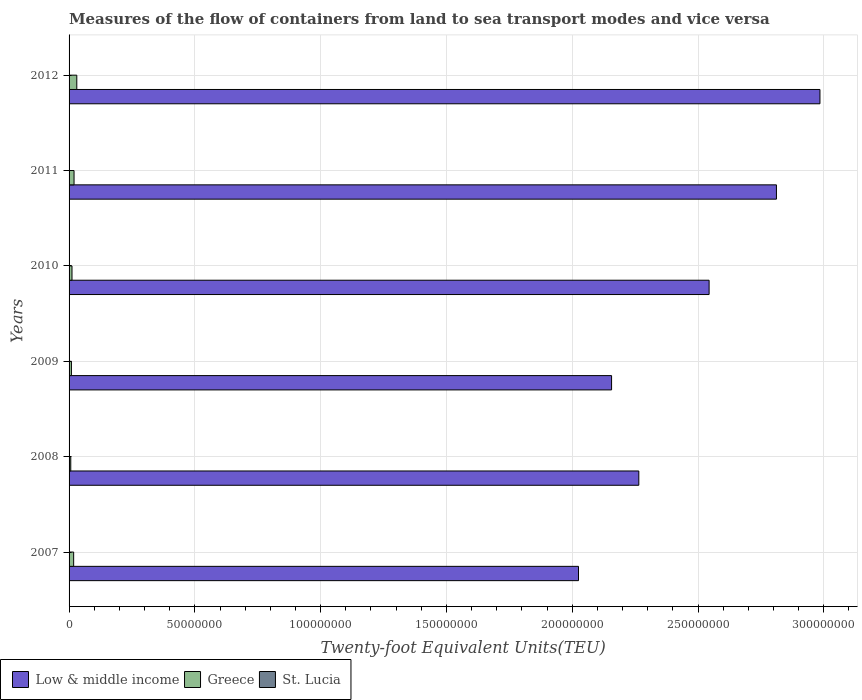How many groups of bars are there?
Your response must be concise. 6. How many bars are there on the 4th tick from the bottom?
Keep it short and to the point. 3. What is the container port traffic in St. Lucia in 2011?
Keep it short and to the point. 5.85e+04. Across all years, what is the maximum container port traffic in Greece?
Provide a succinct answer. 3.07e+06. Across all years, what is the minimum container port traffic in St. Lucia?
Give a very brief answer. 5.19e+04. In which year was the container port traffic in Low & middle income minimum?
Make the answer very short. 2007. What is the total container port traffic in St. Lucia in the graph?
Provide a succinct answer. 3.52e+05. What is the difference between the container port traffic in St. Lucia in 2008 and that in 2009?
Keep it short and to the point. 1.83e+04. What is the difference between the container port traffic in Low & middle income in 2009 and the container port traffic in St. Lucia in 2012?
Your response must be concise. 2.16e+08. What is the average container port traffic in Greece per year?
Ensure brevity in your answer.  1.61e+06. In the year 2008, what is the difference between the container port traffic in Low & middle income and container port traffic in St. Lucia?
Your answer should be very brief. 2.26e+08. In how many years, is the container port traffic in Greece greater than 280000000 TEU?
Offer a terse response. 0. What is the ratio of the container port traffic in Low & middle income in 2007 to that in 2008?
Provide a short and direct response. 0.89. Is the difference between the container port traffic in Low & middle income in 2010 and 2011 greater than the difference between the container port traffic in St. Lucia in 2010 and 2011?
Ensure brevity in your answer.  No. What is the difference between the highest and the second highest container port traffic in Greece?
Your response must be concise. 1.09e+06. What is the difference between the highest and the lowest container port traffic in St. Lucia?
Provide a short and direct response. 1.83e+04. In how many years, is the container port traffic in Greece greater than the average container port traffic in Greece taken over all years?
Your answer should be very brief. 3. Is the sum of the container port traffic in Low & middle income in 2008 and 2011 greater than the maximum container port traffic in St. Lucia across all years?
Keep it short and to the point. Yes. What does the 1st bar from the top in 2010 represents?
Your answer should be very brief. St. Lucia. What does the 3rd bar from the bottom in 2008 represents?
Your answer should be very brief. St. Lucia. Is it the case that in every year, the sum of the container port traffic in St. Lucia and container port traffic in Low & middle income is greater than the container port traffic in Greece?
Offer a very short reply. Yes. How many bars are there?
Ensure brevity in your answer.  18. Are all the bars in the graph horizontal?
Offer a terse response. Yes. How many years are there in the graph?
Your response must be concise. 6. Are the values on the major ticks of X-axis written in scientific E-notation?
Your answer should be very brief. No. Does the graph contain any zero values?
Keep it short and to the point. No. Does the graph contain grids?
Provide a succinct answer. Yes. How many legend labels are there?
Your response must be concise. 3. How are the legend labels stacked?
Provide a short and direct response. Horizontal. What is the title of the graph?
Ensure brevity in your answer.  Measures of the flow of containers from land to sea transport modes and vice versa. Does "Barbados" appear as one of the legend labels in the graph?
Ensure brevity in your answer.  No. What is the label or title of the X-axis?
Your answer should be very brief. Twenty-foot Equivalent Units(TEU). What is the Twenty-foot Equivalent Units(TEU) in Low & middle income in 2007?
Provide a succinct answer. 2.02e+08. What is the Twenty-foot Equivalent Units(TEU) in Greece in 2007?
Your response must be concise. 1.82e+06. What is the Twenty-foot Equivalent Units(TEU) of St. Lucia in 2007?
Your response must be concise. 5.56e+04. What is the Twenty-foot Equivalent Units(TEU) in Low & middle income in 2008?
Your answer should be very brief. 2.26e+08. What is the Twenty-foot Equivalent Units(TEU) in Greece in 2008?
Offer a very short reply. 6.73e+05. What is the Twenty-foot Equivalent Units(TEU) in St. Lucia in 2008?
Your answer should be compact. 7.02e+04. What is the Twenty-foot Equivalent Units(TEU) in Low & middle income in 2009?
Offer a very short reply. 2.16e+08. What is the Twenty-foot Equivalent Units(TEU) of Greece in 2009?
Your response must be concise. 9.35e+05. What is the Twenty-foot Equivalent Units(TEU) of St. Lucia in 2009?
Offer a terse response. 5.19e+04. What is the Twenty-foot Equivalent Units(TEU) of Low & middle income in 2010?
Offer a terse response. 2.54e+08. What is the Twenty-foot Equivalent Units(TEU) in Greece in 2010?
Provide a succinct answer. 1.17e+06. What is the Twenty-foot Equivalent Units(TEU) of St. Lucia in 2010?
Offer a terse response. 5.25e+04. What is the Twenty-foot Equivalent Units(TEU) of Low & middle income in 2011?
Provide a succinct answer. 2.81e+08. What is the Twenty-foot Equivalent Units(TEU) in Greece in 2011?
Keep it short and to the point. 1.98e+06. What is the Twenty-foot Equivalent Units(TEU) of St. Lucia in 2011?
Provide a succinct answer. 5.85e+04. What is the Twenty-foot Equivalent Units(TEU) in Low & middle income in 2012?
Ensure brevity in your answer.  2.98e+08. What is the Twenty-foot Equivalent Units(TEU) in Greece in 2012?
Give a very brief answer. 3.07e+06. What is the Twenty-foot Equivalent Units(TEU) of St. Lucia in 2012?
Your response must be concise. 6.29e+04. Across all years, what is the maximum Twenty-foot Equivalent Units(TEU) in Low & middle income?
Your answer should be compact. 2.98e+08. Across all years, what is the maximum Twenty-foot Equivalent Units(TEU) of Greece?
Offer a terse response. 3.07e+06. Across all years, what is the maximum Twenty-foot Equivalent Units(TEU) of St. Lucia?
Make the answer very short. 7.02e+04. Across all years, what is the minimum Twenty-foot Equivalent Units(TEU) of Low & middle income?
Your answer should be compact. 2.02e+08. Across all years, what is the minimum Twenty-foot Equivalent Units(TEU) in Greece?
Your answer should be compact. 6.73e+05. Across all years, what is the minimum Twenty-foot Equivalent Units(TEU) of St. Lucia?
Your answer should be compact. 5.19e+04. What is the total Twenty-foot Equivalent Units(TEU) of Low & middle income in the graph?
Offer a very short reply. 1.48e+09. What is the total Twenty-foot Equivalent Units(TEU) in Greece in the graph?
Give a very brief answer. 9.64e+06. What is the total Twenty-foot Equivalent Units(TEU) of St. Lucia in the graph?
Your response must be concise. 3.52e+05. What is the difference between the Twenty-foot Equivalent Units(TEU) in Low & middle income in 2007 and that in 2008?
Your answer should be very brief. -2.40e+07. What is the difference between the Twenty-foot Equivalent Units(TEU) in Greece in 2007 and that in 2008?
Make the answer very short. 1.15e+06. What is the difference between the Twenty-foot Equivalent Units(TEU) in St. Lucia in 2007 and that in 2008?
Offer a very short reply. -1.46e+04. What is the difference between the Twenty-foot Equivalent Units(TEU) in Low & middle income in 2007 and that in 2009?
Ensure brevity in your answer.  -1.32e+07. What is the difference between the Twenty-foot Equivalent Units(TEU) in Greece in 2007 and that in 2009?
Ensure brevity in your answer.  8.85e+05. What is the difference between the Twenty-foot Equivalent Units(TEU) of St. Lucia in 2007 and that in 2009?
Offer a terse response. 3640. What is the difference between the Twenty-foot Equivalent Units(TEU) in Low & middle income in 2007 and that in 2010?
Keep it short and to the point. -5.19e+07. What is the difference between the Twenty-foot Equivalent Units(TEU) in Greece in 2007 and that in 2010?
Provide a short and direct response. 6.55e+05. What is the difference between the Twenty-foot Equivalent Units(TEU) in St. Lucia in 2007 and that in 2010?
Make the answer very short. 3103. What is the difference between the Twenty-foot Equivalent Units(TEU) in Low & middle income in 2007 and that in 2011?
Offer a terse response. -7.87e+07. What is the difference between the Twenty-foot Equivalent Units(TEU) of Greece in 2007 and that in 2011?
Give a very brief answer. -1.60e+05. What is the difference between the Twenty-foot Equivalent Units(TEU) in St. Lucia in 2007 and that in 2011?
Your answer should be compact. -2956.94. What is the difference between the Twenty-foot Equivalent Units(TEU) of Low & middle income in 2007 and that in 2012?
Offer a terse response. -9.60e+07. What is the difference between the Twenty-foot Equivalent Units(TEU) in Greece in 2007 and that in 2012?
Your response must be concise. -1.25e+06. What is the difference between the Twenty-foot Equivalent Units(TEU) in St. Lucia in 2007 and that in 2012?
Ensure brevity in your answer.  -7347.36. What is the difference between the Twenty-foot Equivalent Units(TEU) of Low & middle income in 2008 and that in 2009?
Give a very brief answer. 1.08e+07. What is the difference between the Twenty-foot Equivalent Units(TEU) of Greece in 2008 and that in 2009?
Provide a short and direct response. -2.63e+05. What is the difference between the Twenty-foot Equivalent Units(TEU) of St. Lucia in 2008 and that in 2009?
Ensure brevity in your answer.  1.83e+04. What is the difference between the Twenty-foot Equivalent Units(TEU) in Low & middle income in 2008 and that in 2010?
Give a very brief answer. -2.79e+07. What is the difference between the Twenty-foot Equivalent Units(TEU) of Greece in 2008 and that in 2010?
Make the answer very short. -4.93e+05. What is the difference between the Twenty-foot Equivalent Units(TEU) of St. Lucia in 2008 and that in 2010?
Ensure brevity in your answer.  1.77e+04. What is the difference between the Twenty-foot Equivalent Units(TEU) in Low & middle income in 2008 and that in 2011?
Provide a short and direct response. -5.47e+07. What is the difference between the Twenty-foot Equivalent Units(TEU) in Greece in 2008 and that in 2011?
Offer a terse response. -1.31e+06. What is the difference between the Twenty-foot Equivalent Units(TEU) of St. Lucia in 2008 and that in 2011?
Ensure brevity in your answer.  1.17e+04. What is the difference between the Twenty-foot Equivalent Units(TEU) in Low & middle income in 2008 and that in 2012?
Your answer should be very brief. -7.20e+07. What is the difference between the Twenty-foot Equivalent Units(TEU) of Greece in 2008 and that in 2012?
Offer a very short reply. -2.40e+06. What is the difference between the Twenty-foot Equivalent Units(TEU) in St. Lucia in 2008 and that in 2012?
Keep it short and to the point. 7272.64. What is the difference between the Twenty-foot Equivalent Units(TEU) of Low & middle income in 2009 and that in 2010?
Make the answer very short. -3.88e+07. What is the difference between the Twenty-foot Equivalent Units(TEU) of Greece in 2009 and that in 2010?
Provide a succinct answer. -2.30e+05. What is the difference between the Twenty-foot Equivalent Units(TEU) in St. Lucia in 2009 and that in 2010?
Your response must be concise. -537. What is the difference between the Twenty-foot Equivalent Units(TEU) in Low & middle income in 2009 and that in 2011?
Keep it short and to the point. -6.55e+07. What is the difference between the Twenty-foot Equivalent Units(TEU) in Greece in 2009 and that in 2011?
Offer a terse response. -1.05e+06. What is the difference between the Twenty-foot Equivalent Units(TEU) in St. Lucia in 2009 and that in 2011?
Keep it short and to the point. -6596.94. What is the difference between the Twenty-foot Equivalent Units(TEU) in Low & middle income in 2009 and that in 2012?
Your response must be concise. -8.28e+07. What is the difference between the Twenty-foot Equivalent Units(TEU) of Greece in 2009 and that in 2012?
Your answer should be compact. -2.13e+06. What is the difference between the Twenty-foot Equivalent Units(TEU) of St. Lucia in 2009 and that in 2012?
Your answer should be compact. -1.10e+04. What is the difference between the Twenty-foot Equivalent Units(TEU) in Low & middle income in 2010 and that in 2011?
Your response must be concise. -2.68e+07. What is the difference between the Twenty-foot Equivalent Units(TEU) in Greece in 2010 and that in 2011?
Ensure brevity in your answer.  -8.15e+05. What is the difference between the Twenty-foot Equivalent Units(TEU) in St. Lucia in 2010 and that in 2011?
Offer a very short reply. -6059.94. What is the difference between the Twenty-foot Equivalent Units(TEU) of Low & middle income in 2010 and that in 2012?
Keep it short and to the point. -4.41e+07. What is the difference between the Twenty-foot Equivalent Units(TEU) in Greece in 2010 and that in 2012?
Give a very brief answer. -1.90e+06. What is the difference between the Twenty-foot Equivalent Units(TEU) in St. Lucia in 2010 and that in 2012?
Make the answer very short. -1.05e+04. What is the difference between the Twenty-foot Equivalent Units(TEU) in Low & middle income in 2011 and that in 2012?
Offer a very short reply. -1.73e+07. What is the difference between the Twenty-foot Equivalent Units(TEU) of Greece in 2011 and that in 2012?
Your response must be concise. -1.09e+06. What is the difference between the Twenty-foot Equivalent Units(TEU) in St. Lucia in 2011 and that in 2012?
Provide a short and direct response. -4390.42. What is the difference between the Twenty-foot Equivalent Units(TEU) in Low & middle income in 2007 and the Twenty-foot Equivalent Units(TEU) in Greece in 2008?
Ensure brevity in your answer.  2.02e+08. What is the difference between the Twenty-foot Equivalent Units(TEU) in Low & middle income in 2007 and the Twenty-foot Equivalent Units(TEU) in St. Lucia in 2008?
Your answer should be compact. 2.02e+08. What is the difference between the Twenty-foot Equivalent Units(TEU) in Greece in 2007 and the Twenty-foot Equivalent Units(TEU) in St. Lucia in 2008?
Make the answer very short. 1.75e+06. What is the difference between the Twenty-foot Equivalent Units(TEU) in Low & middle income in 2007 and the Twenty-foot Equivalent Units(TEU) in Greece in 2009?
Offer a terse response. 2.02e+08. What is the difference between the Twenty-foot Equivalent Units(TEU) of Low & middle income in 2007 and the Twenty-foot Equivalent Units(TEU) of St. Lucia in 2009?
Make the answer very short. 2.02e+08. What is the difference between the Twenty-foot Equivalent Units(TEU) in Greece in 2007 and the Twenty-foot Equivalent Units(TEU) in St. Lucia in 2009?
Provide a succinct answer. 1.77e+06. What is the difference between the Twenty-foot Equivalent Units(TEU) of Low & middle income in 2007 and the Twenty-foot Equivalent Units(TEU) of Greece in 2010?
Ensure brevity in your answer.  2.01e+08. What is the difference between the Twenty-foot Equivalent Units(TEU) of Low & middle income in 2007 and the Twenty-foot Equivalent Units(TEU) of St. Lucia in 2010?
Keep it short and to the point. 2.02e+08. What is the difference between the Twenty-foot Equivalent Units(TEU) of Greece in 2007 and the Twenty-foot Equivalent Units(TEU) of St. Lucia in 2010?
Give a very brief answer. 1.77e+06. What is the difference between the Twenty-foot Equivalent Units(TEU) of Low & middle income in 2007 and the Twenty-foot Equivalent Units(TEU) of Greece in 2011?
Offer a very short reply. 2.01e+08. What is the difference between the Twenty-foot Equivalent Units(TEU) of Low & middle income in 2007 and the Twenty-foot Equivalent Units(TEU) of St. Lucia in 2011?
Your response must be concise. 2.02e+08. What is the difference between the Twenty-foot Equivalent Units(TEU) in Greece in 2007 and the Twenty-foot Equivalent Units(TEU) in St. Lucia in 2011?
Keep it short and to the point. 1.76e+06. What is the difference between the Twenty-foot Equivalent Units(TEU) of Low & middle income in 2007 and the Twenty-foot Equivalent Units(TEU) of Greece in 2012?
Offer a terse response. 1.99e+08. What is the difference between the Twenty-foot Equivalent Units(TEU) of Low & middle income in 2007 and the Twenty-foot Equivalent Units(TEU) of St. Lucia in 2012?
Ensure brevity in your answer.  2.02e+08. What is the difference between the Twenty-foot Equivalent Units(TEU) of Greece in 2007 and the Twenty-foot Equivalent Units(TEU) of St. Lucia in 2012?
Provide a succinct answer. 1.76e+06. What is the difference between the Twenty-foot Equivalent Units(TEU) in Low & middle income in 2008 and the Twenty-foot Equivalent Units(TEU) in Greece in 2009?
Keep it short and to the point. 2.26e+08. What is the difference between the Twenty-foot Equivalent Units(TEU) in Low & middle income in 2008 and the Twenty-foot Equivalent Units(TEU) in St. Lucia in 2009?
Make the answer very short. 2.26e+08. What is the difference between the Twenty-foot Equivalent Units(TEU) of Greece in 2008 and the Twenty-foot Equivalent Units(TEU) of St. Lucia in 2009?
Give a very brief answer. 6.21e+05. What is the difference between the Twenty-foot Equivalent Units(TEU) in Low & middle income in 2008 and the Twenty-foot Equivalent Units(TEU) in Greece in 2010?
Your response must be concise. 2.25e+08. What is the difference between the Twenty-foot Equivalent Units(TEU) of Low & middle income in 2008 and the Twenty-foot Equivalent Units(TEU) of St. Lucia in 2010?
Keep it short and to the point. 2.26e+08. What is the difference between the Twenty-foot Equivalent Units(TEU) of Greece in 2008 and the Twenty-foot Equivalent Units(TEU) of St. Lucia in 2010?
Make the answer very short. 6.20e+05. What is the difference between the Twenty-foot Equivalent Units(TEU) in Low & middle income in 2008 and the Twenty-foot Equivalent Units(TEU) in Greece in 2011?
Provide a succinct answer. 2.24e+08. What is the difference between the Twenty-foot Equivalent Units(TEU) of Low & middle income in 2008 and the Twenty-foot Equivalent Units(TEU) of St. Lucia in 2011?
Your answer should be compact. 2.26e+08. What is the difference between the Twenty-foot Equivalent Units(TEU) in Greece in 2008 and the Twenty-foot Equivalent Units(TEU) in St. Lucia in 2011?
Your answer should be very brief. 6.14e+05. What is the difference between the Twenty-foot Equivalent Units(TEU) in Low & middle income in 2008 and the Twenty-foot Equivalent Units(TEU) in Greece in 2012?
Keep it short and to the point. 2.23e+08. What is the difference between the Twenty-foot Equivalent Units(TEU) in Low & middle income in 2008 and the Twenty-foot Equivalent Units(TEU) in St. Lucia in 2012?
Ensure brevity in your answer.  2.26e+08. What is the difference between the Twenty-foot Equivalent Units(TEU) in Greece in 2008 and the Twenty-foot Equivalent Units(TEU) in St. Lucia in 2012?
Ensure brevity in your answer.  6.10e+05. What is the difference between the Twenty-foot Equivalent Units(TEU) in Low & middle income in 2009 and the Twenty-foot Equivalent Units(TEU) in Greece in 2010?
Your response must be concise. 2.14e+08. What is the difference between the Twenty-foot Equivalent Units(TEU) of Low & middle income in 2009 and the Twenty-foot Equivalent Units(TEU) of St. Lucia in 2010?
Provide a succinct answer. 2.16e+08. What is the difference between the Twenty-foot Equivalent Units(TEU) of Greece in 2009 and the Twenty-foot Equivalent Units(TEU) of St. Lucia in 2010?
Ensure brevity in your answer.  8.83e+05. What is the difference between the Twenty-foot Equivalent Units(TEU) in Low & middle income in 2009 and the Twenty-foot Equivalent Units(TEU) in Greece in 2011?
Make the answer very short. 2.14e+08. What is the difference between the Twenty-foot Equivalent Units(TEU) of Low & middle income in 2009 and the Twenty-foot Equivalent Units(TEU) of St. Lucia in 2011?
Your answer should be very brief. 2.16e+08. What is the difference between the Twenty-foot Equivalent Units(TEU) of Greece in 2009 and the Twenty-foot Equivalent Units(TEU) of St. Lucia in 2011?
Make the answer very short. 8.77e+05. What is the difference between the Twenty-foot Equivalent Units(TEU) in Low & middle income in 2009 and the Twenty-foot Equivalent Units(TEU) in Greece in 2012?
Your response must be concise. 2.13e+08. What is the difference between the Twenty-foot Equivalent Units(TEU) of Low & middle income in 2009 and the Twenty-foot Equivalent Units(TEU) of St. Lucia in 2012?
Your answer should be very brief. 2.16e+08. What is the difference between the Twenty-foot Equivalent Units(TEU) of Greece in 2009 and the Twenty-foot Equivalent Units(TEU) of St. Lucia in 2012?
Offer a terse response. 8.72e+05. What is the difference between the Twenty-foot Equivalent Units(TEU) in Low & middle income in 2010 and the Twenty-foot Equivalent Units(TEU) in Greece in 2011?
Your answer should be compact. 2.52e+08. What is the difference between the Twenty-foot Equivalent Units(TEU) in Low & middle income in 2010 and the Twenty-foot Equivalent Units(TEU) in St. Lucia in 2011?
Your answer should be compact. 2.54e+08. What is the difference between the Twenty-foot Equivalent Units(TEU) of Greece in 2010 and the Twenty-foot Equivalent Units(TEU) of St. Lucia in 2011?
Give a very brief answer. 1.11e+06. What is the difference between the Twenty-foot Equivalent Units(TEU) of Low & middle income in 2010 and the Twenty-foot Equivalent Units(TEU) of Greece in 2012?
Provide a succinct answer. 2.51e+08. What is the difference between the Twenty-foot Equivalent Units(TEU) of Low & middle income in 2010 and the Twenty-foot Equivalent Units(TEU) of St. Lucia in 2012?
Offer a very short reply. 2.54e+08. What is the difference between the Twenty-foot Equivalent Units(TEU) in Greece in 2010 and the Twenty-foot Equivalent Units(TEU) in St. Lucia in 2012?
Give a very brief answer. 1.10e+06. What is the difference between the Twenty-foot Equivalent Units(TEU) in Low & middle income in 2011 and the Twenty-foot Equivalent Units(TEU) in Greece in 2012?
Your answer should be compact. 2.78e+08. What is the difference between the Twenty-foot Equivalent Units(TEU) of Low & middle income in 2011 and the Twenty-foot Equivalent Units(TEU) of St. Lucia in 2012?
Your response must be concise. 2.81e+08. What is the difference between the Twenty-foot Equivalent Units(TEU) of Greece in 2011 and the Twenty-foot Equivalent Units(TEU) of St. Lucia in 2012?
Offer a terse response. 1.92e+06. What is the average Twenty-foot Equivalent Units(TEU) in Low & middle income per year?
Provide a succinct answer. 2.46e+08. What is the average Twenty-foot Equivalent Units(TEU) in Greece per year?
Keep it short and to the point. 1.61e+06. What is the average Twenty-foot Equivalent Units(TEU) in St. Lucia per year?
Give a very brief answer. 5.86e+04. In the year 2007, what is the difference between the Twenty-foot Equivalent Units(TEU) in Low & middle income and Twenty-foot Equivalent Units(TEU) in Greece?
Provide a short and direct response. 2.01e+08. In the year 2007, what is the difference between the Twenty-foot Equivalent Units(TEU) in Low & middle income and Twenty-foot Equivalent Units(TEU) in St. Lucia?
Keep it short and to the point. 2.02e+08. In the year 2007, what is the difference between the Twenty-foot Equivalent Units(TEU) in Greece and Twenty-foot Equivalent Units(TEU) in St. Lucia?
Your answer should be compact. 1.76e+06. In the year 2008, what is the difference between the Twenty-foot Equivalent Units(TEU) of Low & middle income and Twenty-foot Equivalent Units(TEU) of Greece?
Offer a terse response. 2.26e+08. In the year 2008, what is the difference between the Twenty-foot Equivalent Units(TEU) of Low & middle income and Twenty-foot Equivalent Units(TEU) of St. Lucia?
Offer a terse response. 2.26e+08. In the year 2008, what is the difference between the Twenty-foot Equivalent Units(TEU) of Greece and Twenty-foot Equivalent Units(TEU) of St. Lucia?
Give a very brief answer. 6.02e+05. In the year 2009, what is the difference between the Twenty-foot Equivalent Units(TEU) of Low & middle income and Twenty-foot Equivalent Units(TEU) of Greece?
Your response must be concise. 2.15e+08. In the year 2009, what is the difference between the Twenty-foot Equivalent Units(TEU) in Low & middle income and Twenty-foot Equivalent Units(TEU) in St. Lucia?
Keep it short and to the point. 2.16e+08. In the year 2009, what is the difference between the Twenty-foot Equivalent Units(TEU) in Greece and Twenty-foot Equivalent Units(TEU) in St. Lucia?
Your answer should be very brief. 8.83e+05. In the year 2010, what is the difference between the Twenty-foot Equivalent Units(TEU) of Low & middle income and Twenty-foot Equivalent Units(TEU) of Greece?
Offer a very short reply. 2.53e+08. In the year 2010, what is the difference between the Twenty-foot Equivalent Units(TEU) of Low & middle income and Twenty-foot Equivalent Units(TEU) of St. Lucia?
Your response must be concise. 2.54e+08. In the year 2010, what is the difference between the Twenty-foot Equivalent Units(TEU) of Greece and Twenty-foot Equivalent Units(TEU) of St. Lucia?
Offer a terse response. 1.11e+06. In the year 2011, what is the difference between the Twenty-foot Equivalent Units(TEU) in Low & middle income and Twenty-foot Equivalent Units(TEU) in Greece?
Offer a very short reply. 2.79e+08. In the year 2011, what is the difference between the Twenty-foot Equivalent Units(TEU) of Low & middle income and Twenty-foot Equivalent Units(TEU) of St. Lucia?
Give a very brief answer. 2.81e+08. In the year 2011, what is the difference between the Twenty-foot Equivalent Units(TEU) of Greece and Twenty-foot Equivalent Units(TEU) of St. Lucia?
Your answer should be very brief. 1.92e+06. In the year 2012, what is the difference between the Twenty-foot Equivalent Units(TEU) in Low & middle income and Twenty-foot Equivalent Units(TEU) in Greece?
Keep it short and to the point. 2.95e+08. In the year 2012, what is the difference between the Twenty-foot Equivalent Units(TEU) in Low & middle income and Twenty-foot Equivalent Units(TEU) in St. Lucia?
Provide a short and direct response. 2.98e+08. In the year 2012, what is the difference between the Twenty-foot Equivalent Units(TEU) of Greece and Twenty-foot Equivalent Units(TEU) of St. Lucia?
Give a very brief answer. 3.01e+06. What is the ratio of the Twenty-foot Equivalent Units(TEU) in Low & middle income in 2007 to that in 2008?
Keep it short and to the point. 0.89. What is the ratio of the Twenty-foot Equivalent Units(TEU) in Greece in 2007 to that in 2008?
Keep it short and to the point. 2.71. What is the ratio of the Twenty-foot Equivalent Units(TEU) in St. Lucia in 2007 to that in 2008?
Offer a very short reply. 0.79. What is the ratio of the Twenty-foot Equivalent Units(TEU) of Low & middle income in 2007 to that in 2009?
Provide a succinct answer. 0.94. What is the ratio of the Twenty-foot Equivalent Units(TEU) in Greece in 2007 to that in 2009?
Provide a succinct answer. 1.95. What is the ratio of the Twenty-foot Equivalent Units(TEU) in St. Lucia in 2007 to that in 2009?
Offer a very short reply. 1.07. What is the ratio of the Twenty-foot Equivalent Units(TEU) of Low & middle income in 2007 to that in 2010?
Provide a short and direct response. 0.8. What is the ratio of the Twenty-foot Equivalent Units(TEU) in Greece in 2007 to that in 2010?
Your response must be concise. 1.56. What is the ratio of the Twenty-foot Equivalent Units(TEU) of St. Lucia in 2007 to that in 2010?
Provide a succinct answer. 1.06. What is the ratio of the Twenty-foot Equivalent Units(TEU) in Low & middle income in 2007 to that in 2011?
Provide a succinct answer. 0.72. What is the ratio of the Twenty-foot Equivalent Units(TEU) in Greece in 2007 to that in 2011?
Provide a short and direct response. 0.92. What is the ratio of the Twenty-foot Equivalent Units(TEU) in St. Lucia in 2007 to that in 2011?
Ensure brevity in your answer.  0.95. What is the ratio of the Twenty-foot Equivalent Units(TEU) in Low & middle income in 2007 to that in 2012?
Your response must be concise. 0.68. What is the ratio of the Twenty-foot Equivalent Units(TEU) in Greece in 2007 to that in 2012?
Give a very brief answer. 0.59. What is the ratio of the Twenty-foot Equivalent Units(TEU) of St. Lucia in 2007 to that in 2012?
Your answer should be very brief. 0.88. What is the ratio of the Twenty-foot Equivalent Units(TEU) of Low & middle income in 2008 to that in 2009?
Keep it short and to the point. 1.05. What is the ratio of the Twenty-foot Equivalent Units(TEU) in Greece in 2008 to that in 2009?
Make the answer very short. 0.72. What is the ratio of the Twenty-foot Equivalent Units(TEU) of St. Lucia in 2008 to that in 2009?
Offer a terse response. 1.35. What is the ratio of the Twenty-foot Equivalent Units(TEU) of Low & middle income in 2008 to that in 2010?
Keep it short and to the point. 0.89. What is the ratio of the Twenty-foot Equivalent Units(TEU) of Greece in 2008 to that in 2010?
Ensure brevity in your answer.  0.58. What is the ratio of the Twenty-foot Equivalent Units(TEU) of St. Lucia in 2008 to that in 2010?
Your response must be concise. 1.34. What is the ratio of the Twenty-foot Equivalent Units(TEU) of Low & middle income in 2008 to that in 2011?
Ensure brevity in your answer.  0.81. What is the ratio of the Twenty-foot Equivalent Units(TEU) in Greece in 2008 to that in 2011?
Your response must be concise. 0.34. What is the ratio of the Twenty-foot Equivalent Units(TEU) in St. Lucia in 2008 to that in 2011?
Provide a succinct answer. 1.2. What is the ratio of the Twenty-foot Equivalent Units(TEU) in Low & middle income in 2008 to that in 2012?
Your answer should be compact. 0.76. What is the ratio of the Twenty-foot Equivalent Units(TEU) of Greece in 2008 to that in 2012?
Keep it short and to the point. 0.22. What is the ratio of the Twenty-foot Equivalent Units(TEU) in St. Lucia in 2008 to that in 2012?
Make the answer very short. 1.12. What is the ratio of the Twenty-foot Equivalent Units(TEU) in Low & middle income in 2009 to that in 2010?
Offer a very short reply. 0.85. What is the ratio of the Twenty-foot Equivalent Units(TEU) of Greece in 2009 to that in 2010?
Your answer should be compact. 0.8. What is the ratio of the Twenty-foot Equivalent Units(TEU) of Low & middle income in 2009 to that in 2011?
Provide a short and direct response. 0.77. What is the ratio of the Twenty-foot Equivalent Units(TEU) of Greece in 2009 to that in 2011?
Your response must be concise. 0.47. What is the ratio of the Twenty-foot Equivalent Units(TEU) of St. Lucia in 2009 to that in 2011?
Your answer should be compact. 0.89. What is the ratio of the Twenty-foot Equivalent Units(TEU) in Low & middle income in 2009 to that in 2012?
Make the answer very short. 0.72. What is the ratio of the Twenty-foot Equivalent Units(TEU) in Greece in 2009 to that in 2012?
Provide a succinct answer. 0.3. What is the ratio of the Twenty-foot Equivalent Units(TEU) in St. Lucia in 2009 to that in 2012?
Give a very brief answer. 0.83. What is the ratio of the Twenty-foot Equivalent Units(TEU) of Low & middle income in 2010 to that in 2011?
Keep it short and to the point. 0.9. What is the ratio of the Twenty-foot Equivalent Units(TEU) of Greece in 2010 to that in 2011?
Your response must be concise. 0.59. What is the ratio of the Twenty-foot Equivalent Units(TEU) of St. Lucia in 2010 to that in 2011?
Your response must be concise. 0.9. What is the ratio of the Twenty-foot Equivalent Units(TEU) of Low & middle income in 2010 to that in 2012?
Your response must be concise. 0.85. What is the ratio of the Twenty-foot Equivalent Units(TEU) in Greece in 2010 to that in 2012?
Offer a very short reply. 0.38. What is the ratio of the Twenty-foot Equivalent Units(TEU) in St. Lucia in 2010 to that in 2012?
Offer a very short reply. 0.83. What is the ratio of the Twenty-foot Equivalent Units(TEU) of Low & middle income in 2011 to that in 2012?
Make the answer very short. 0.94. What is the ratio of the Twenty-foot Equivalent Units(TEU) of Greece in 2011 to that in 2012?
Make the answer very short. 0.65. What is the ratio of the Twenty-foot Equivalent Units(TEU) of St. Lucia in 2011 to that in 2012?
Make the answer very short. 0.93. What is the difference between the highest and the second highest Twenty-foot Equivalent Units(TEU) of Low & middle income?
Your response must be concise. 1.73e+07. What is the difference between the highest and the second highest Twenty-foot Equivalent Units(TEU) in Greece?
Your response must be concise. 1.09e+06. What is the difference between the highest and the second highest Twenty-foot Equivalent Units(TEU) of St. Lucia?
Provide a short and direct response. 7272.64. What is the difference between the highest and the lowest Twenty-foot Equivalent Units(TEU) of Low & middle income?
Offer a terse response. 9.60e+07. What is the difference between the highest and the lowest Twenty-foot Equivalent Units(TEU) in Greece?
Your response must be concise. 2.40e+06. What is the difference between the highest and the lowest Twenty-foot Equivalent Units(TEU) in St. Lucia?
Provide a succinct answer. 1.83e+04. 